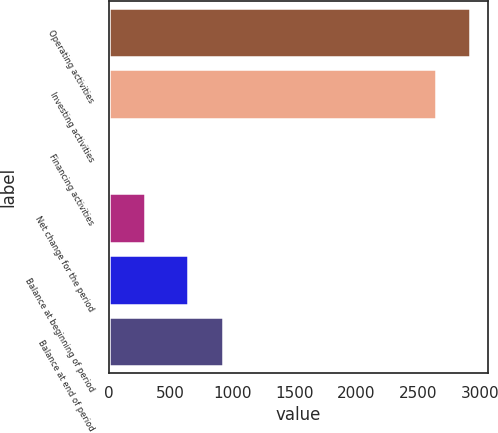Convert chart to OTSL. <chart><loc_0><loc_0><loc_500><loc_500><bar_chart><fcel>Operating activities<fcel>Investing activities<fcel>Financing activities<fcel>Net change for the period<fcel>Balance at beginning of period<fcel>Balance at end of period<nl><fcel>2918.2<fcel>2638<fcel>17<fcel>297.2<fcel>645<fcel>925.2<nl></chart> 